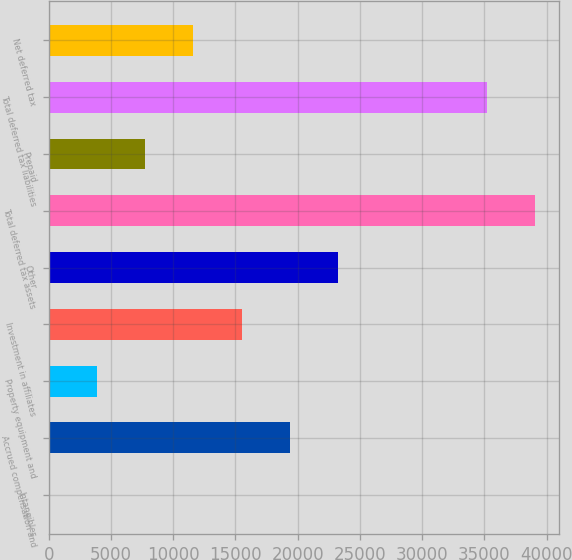Convert chart. <chart><loc_0><loc_0><loc_500><loc_500><bar_chart><fcel>Intangibles<fcel>Accrued compensation and<fcel>Property equipment and<fcel>Investment in affiliates<fcel>Other<fcel>Total deferred tax assets<fcel>Prepaid<fcel>Total deferred tax liabilities<fcel>Net deferred tax<nl><fcel>32<fcel>19360<fcel>3897.6<fcel>15494.4<fcel>23225.6<fcel>39059.6<fcel>7763.2<fcel>35194<fcel>11628.8<nl></chart> 